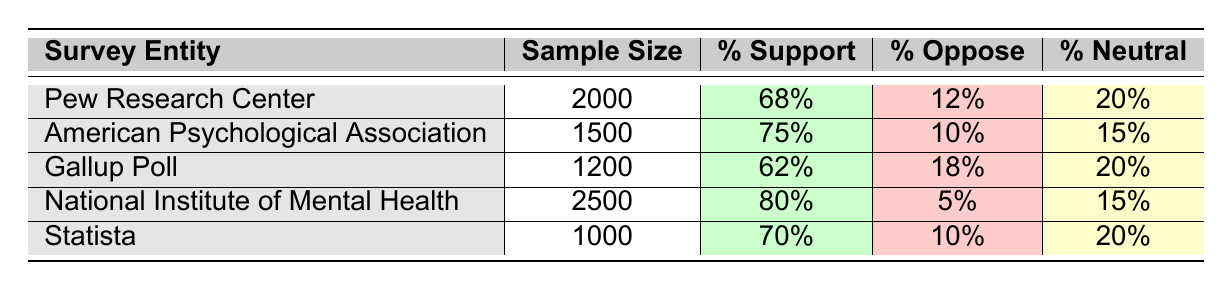What was the sample size of the American Psychological Association's survey? The table lists the details for each survey, and the sample size for the American Psychological Association is clearly stated as 1500.
Answer: 1500 Which survey entity reported the highest percentage of support for psychological therapies? By comparing the "Percentage Support" column for each survey entity, the National Institute of Mental Health shows the highest percentage at 80%.
Answer: National Institute of Mental Health What is the average percentage of opposition to psychological therapies across all surveys? To find the average percentage of opposition, we add the percentages from all surveys (12 + 10 + 18 + 5 + 10 = 55) and divide by the number of surveys (5), resulting in an average of 55/5 = 11%.
Answer: 11% Did Statista report a higher percentage of people supporting psychological therapies than Gallup Poll? Comparing the "Percentage Support" values for Statista (70%) and Gallup Poll (62%), we see that Statista has a higher percentage of support. Therefore, the answer is yes.
Answer: Yes What percentage of respondents from the Pew Research Center were neutral regarding psychological therapies? The "Percentage Neutral" column shows that the Pew Research Center reported 20% of respondents were neutral.
Answer: 20% What is the total sample size represented across all the surveyed entities? To find the total sample size, we add the sample sizes from all surveys (2000 + 1500 + 1200 + 2500 + 1000 = 9200).
Answer: 9200 Which survey had a neutral percentage that is less than or equal to 20%? By reviewing the "Percentage Neutral" column, all surveys except for Gallup Poll, Pew Research Center, and Statista report percentages of 20%, while American Psychological Association is at 15%, and National Institute of Mental Health is at 15%.
Answer: Yes What is the difference in percentage support for psychological therapies between the National Institute of Mental Health and Pew Research Center? The percentage support for the National Institute of Mental Health is 80%, and for the Pew Research Center, it is 68%. The difference is 80 - 68 = 12%.
Answer: 12% 